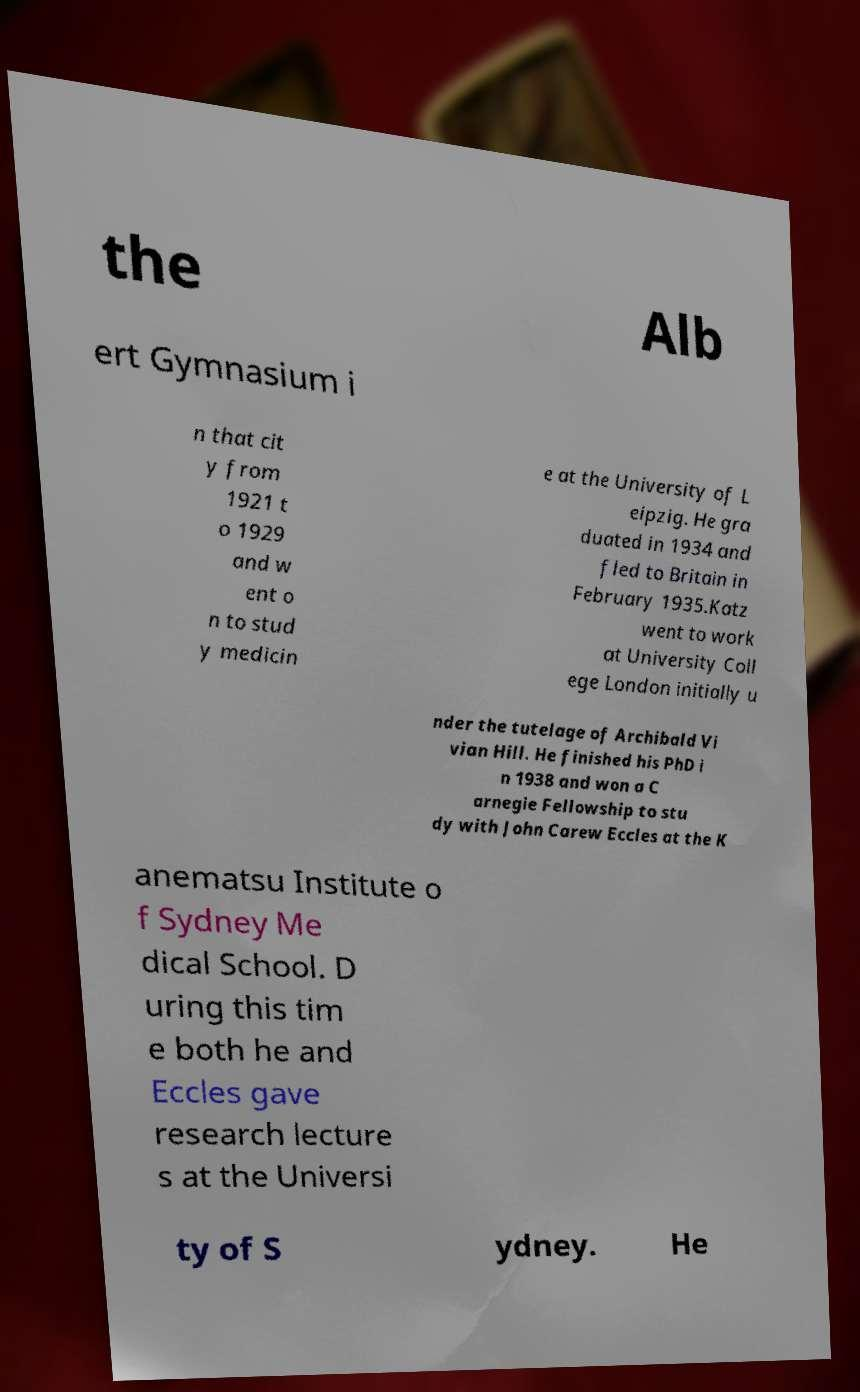Can you read and provide the text displayed in the image?This photo seems to have some interesting text. Can you extract and type it out for me? the Alb ert Gymnasium i n that cit y from 1921 t o 1929 and w ent o n to stud y medicin e at the University of L eipzig. He gra duated in 1934 and fled to Britain in February 1935.Katz went to work at University Coll ege London initially u nder the tutelage of Archibald Vi vian Hill. He finished his PhD i n 1938 and won a C arnegie Fellowship to stu dy with John Carew Eccles at the K anematsu Institute o f Sydney Me dical School. D uring this tim e both he and Eccles gave research lecture s at the Universi ty of S ydney. He 